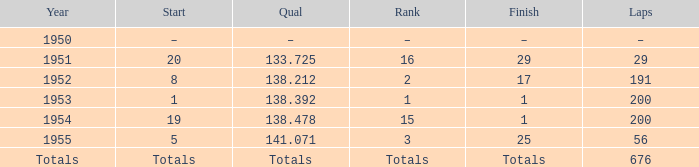What finish qualified at 141.071? 25.0. 